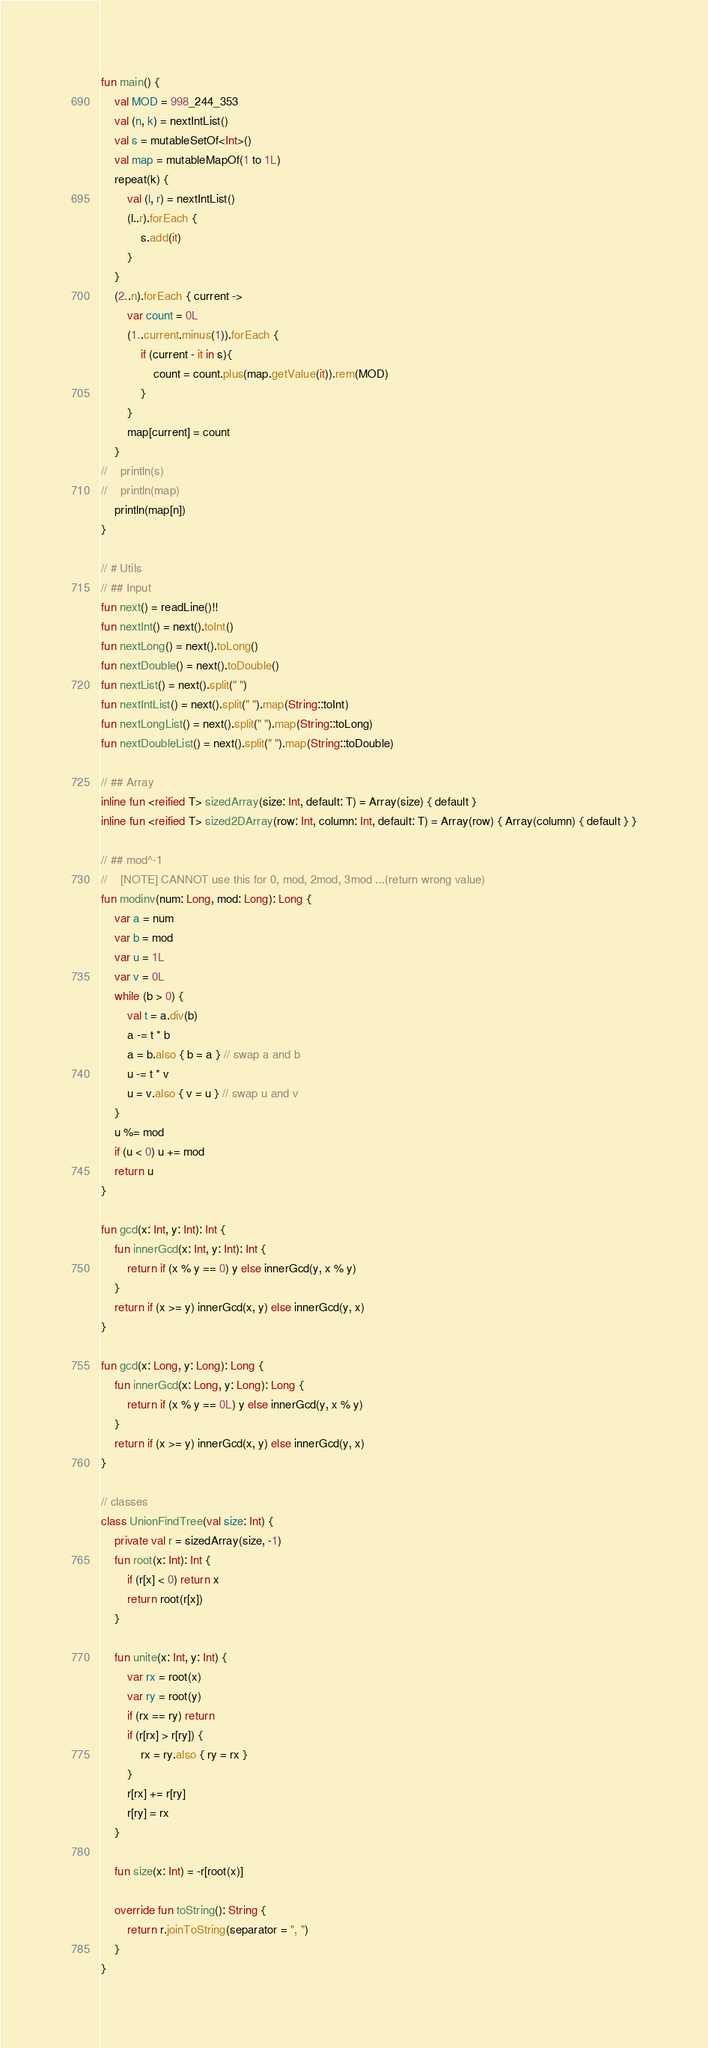Convert code to text. <code><loc_0><loc_0><loc_500><loc_500><_Kotlin_>fun main() {
    val MOD = 998_244_353
    val (n, k) = nextIntList()
    val s = mutableSetOf<Int>()
    val map = mutableMapOf(1 to 1L)
    repeat(k) {
        val (l, r) = nextIntList()
        (l..r).forEach {
            s.add(it)
        }
    }
    (2..n).forEach { current ->
        var count = 0L
        (1..current.minus(1)).forEach {
            if (current - it in s){
                count = count.plus(map.getValue(it)).rem(MOD)
            }
        }
        map[current] = count
    }
//    println(s)
//    println(map)
    println(map[n])
}

// # Utils
// ## Input
fun next() = readLine()!!
fun nextInt() = next().toInt()
fun nextLong() = next().toLong()
fun nextDouble() = next().toDouble()
fun nextList() = next().split(" ")
fun nextIntList() = next().split(" ").map(String::toInt)
fun nextLongList() = next().split(" ").map(String::toLong)
fun nextDoubleList() = next().split(" ").map(String::toDouble)

// ## Array
inline fun <reified T> sizedArray(size: Int, default: T) = Array(size) { default }
inline fun <reified T> sized2DArray(row: Int, column: Int, default: T) = Array(row) { Array(column) { default } }

// ## mod^-1
//    [NOTE] CANNOT use this for 0, mod, 2mod, 3mod ...(return wrong value)
fun modinv(num: Long, mod: Long): Long {
    var a = num
    var b = mod
    var u = 1L
    var v = 0L
    while (b > 0) {
        val t = a.div(b)
        a -= t * b
        a = b.also { b = a } // swap a and b
        u -= t * v
        u = v.also { v = u } // swap u and v
    }
    u %= mod
    if (u < 0) u += mod
    return u
}

fun gcd(x: Int, y: Int): Int {
    fun innerGcd(x: Int, y: Int): Int {
        return if (x % y == 0) y else innerGcd(y, x % y)
    }
    return if (x >= y) innerGcd(x, y) else innerGcd(y, x)
}

fun gcd(x: Long, y: Long): Long {
    fun innerGcd(x: Long, y: Long): Long {
        return if (x % y == 0L) y else innerGcd(y, x % y)
    }
    return if (x >= y) innerGcd(x, y) else innerGcd(y, x)
}

// classes
class UnionFindTree(val size: Int) {
    private val r = sizedArray(size, -1)
    fun root(x: Int): Int {
        if (r[x] < 0) return x
        return root(r[x])
    }

    fun unite(x: Int, y: Int) {
        var rx = root(x)
        var ry = root(y)
        if (rx == ry) return
        if (r[rx] > r[ry]) {
            rx = ry.also { ry = rx }
        }
        r[rx] += r[ry]
        r[ry] = rx
    }

    fun size(x: Int) = -r[root(x)]

    override fun toString(): String {
        return r.joinToString(separator = ", ")
    }
}</code> 